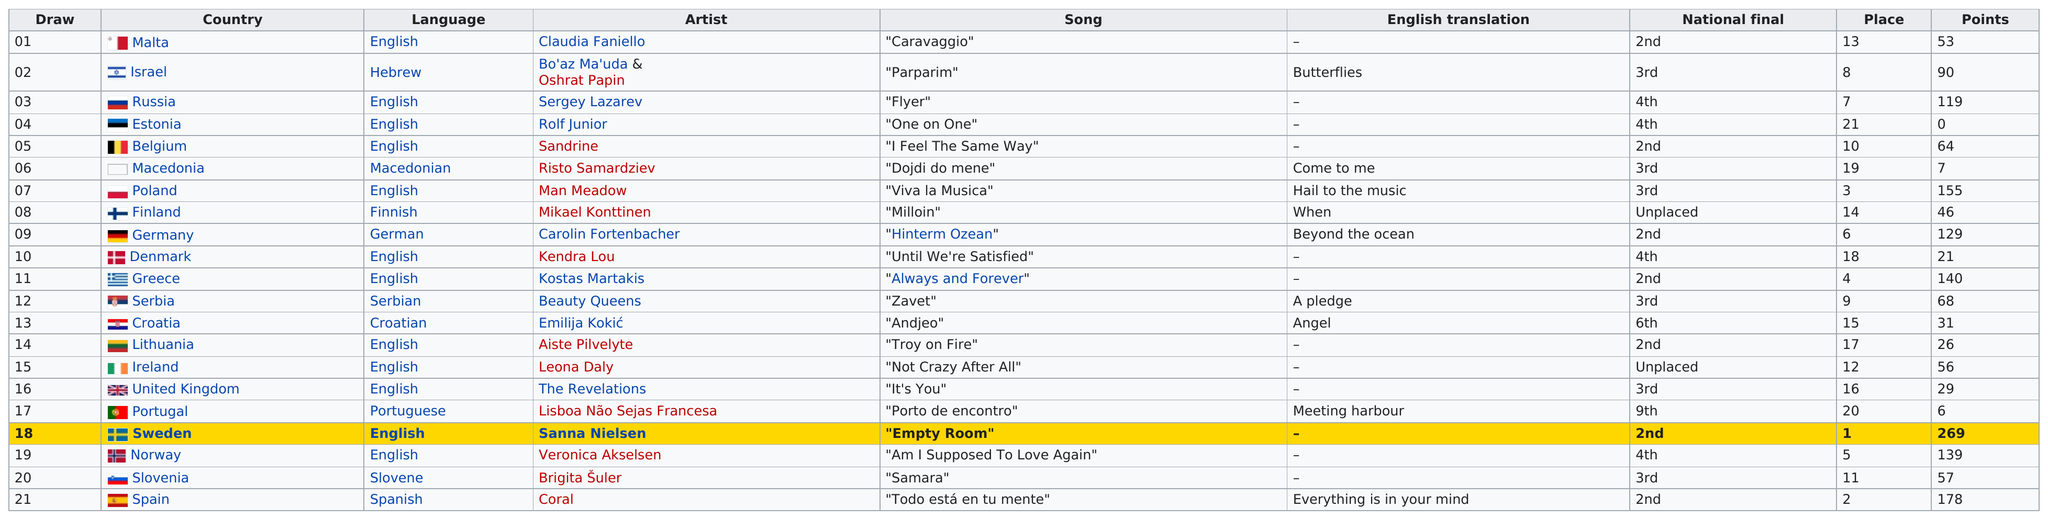List a handful of essential elements in this visual. Sweden is the top placed country. The artist who is next to the language in Draw 12 is Beauty Queens. Six countries, other than Spain, placed second in their national finals. In the 2008 OGAE Second Chance Contest, Estonia received the least amount of points among all participating countries. Draw 17 is in Portugal. 